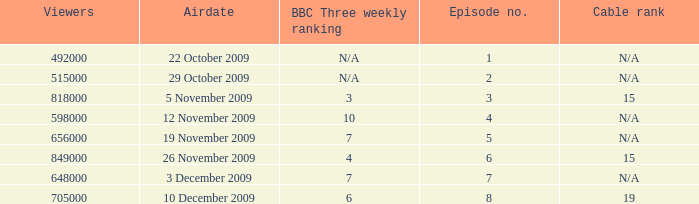Can you parse all the data within this table? {'header': ['Viewers', 'Airdate', 'BBC Three weekly ranking', 'Episode no.', 'Cable rank'], 'rows': [['492000', '22 October 2009', 'N/A', '1', 'N/A'], ['515000', '29 October 2009', 'N/A', '2', 'N/A'], ['818000', '5 November 2009', '3', '3', '15'], ['598000', '12 November 2009', '10', '4', 'N/A'], ['656000', '19 November 2009', '7', '5', 'N/A'], ['849000', '26 November 2009', '4', '6', '15'], ['648000', '3 December 2009', '7', '7', 'N/A'], ['705000', '10 December 2009', '6', '8', '19']]} How many viewers were there for airdate is 22 october 2009? 492000.0. 